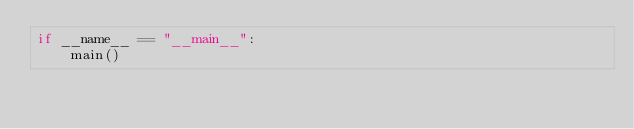Convert code to text. <code><loc_0><loc_0><loc_500><loc_500><_Python_>if __name__ == "__main__":
    main()
</code> 